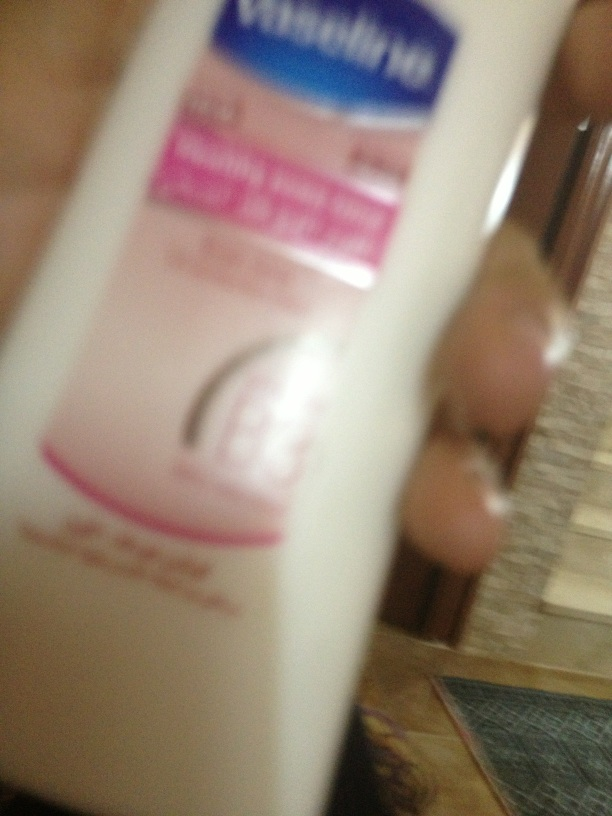If this lotion were part of someone's daily routine, what might a typical day look like for them? A typical day for someone who uses Vaseline lotion might start with a morning shower, followed by applying the lotion to lock in moisture and prepare their skin for the day ahead. Throughout the day, they might reapply a small amount to their hands after washing to keep them soft and protected. In the evening, they might use it again after another shower or bath, ensuring their skin stays hydrated overnight. This routine helps them maintain smooth, healthy skin every day, providing relief from dryness and protecting against environmental factors. In a quick overview, why might someone choose this lotion over others? Someone might choose Vaseline lotion over others because it's known for being highly effective, affordable, and reliable. Its formulation with petroleum jelly creates a strong barrier that locks in moisture, making it particularly good for very dry skin. It's also widely available and has a longstanding reputation for quality. 